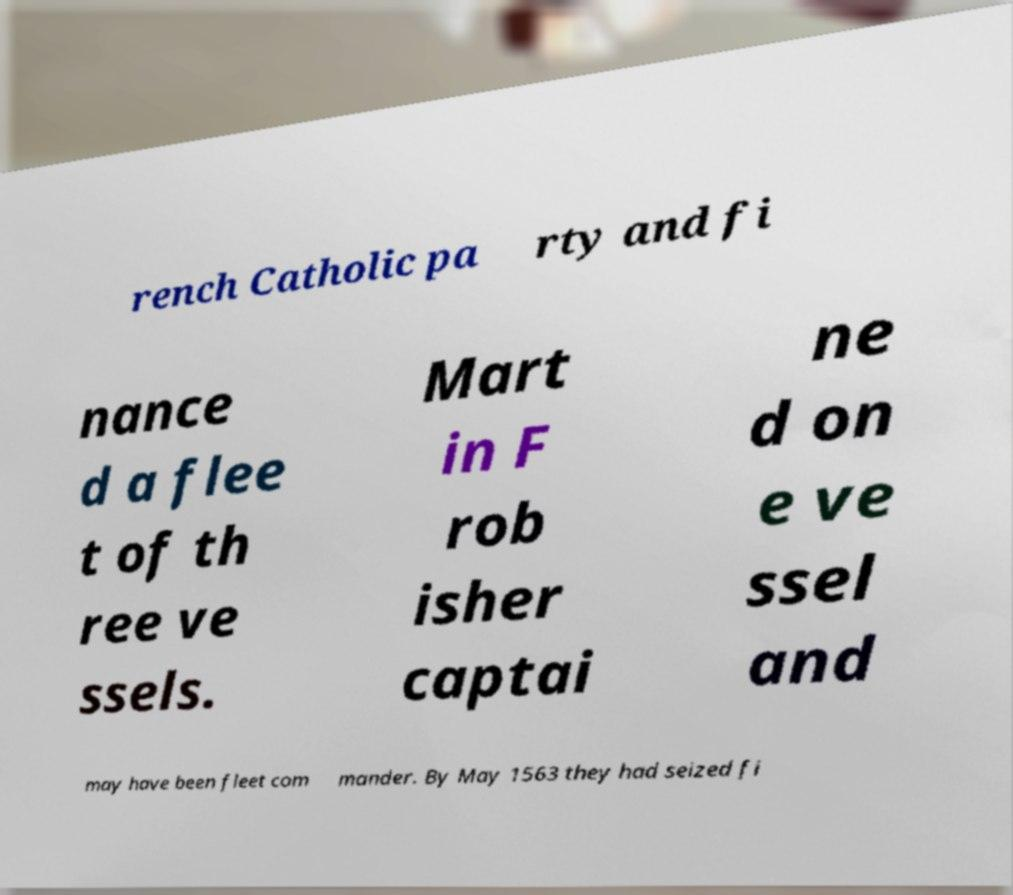Could you assist in decoding the text presented in this image and type it out clearly? rench Catholic pa rty and fi nance d a flee t of th ree ve ssels. Mart in F rob isher captai ne d on e ve ssel and may have been fleet com mander. By May 1563 they had seized fi 